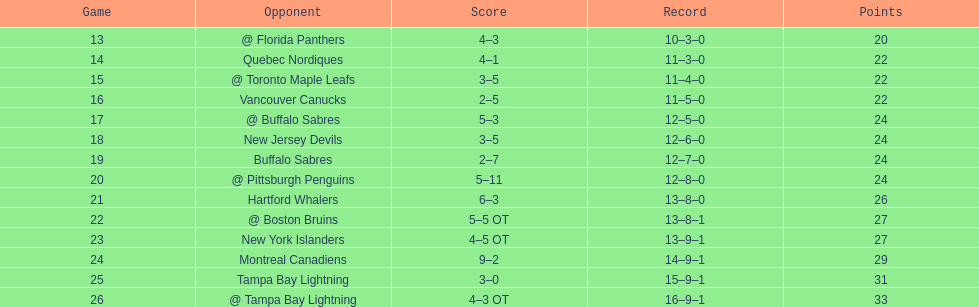Who had the most assists on the 1993-1994 flyers? Mark Recchi. 